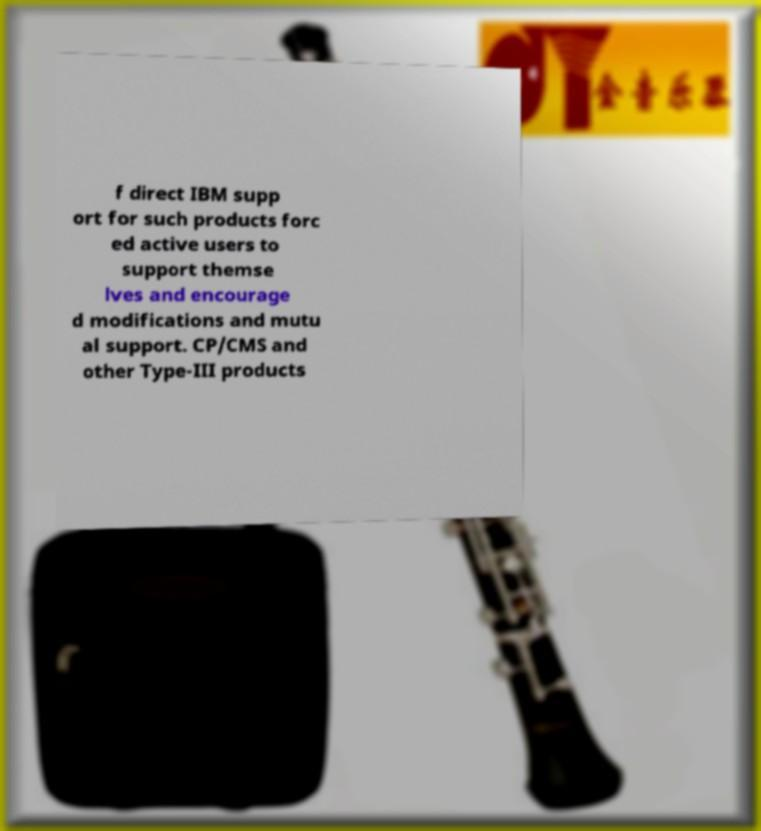Could you extract and type out the text from this image? f direct IBM supp ort for such products forc ed active users to support themse lves and encourage d modifications and mutu al support. CP/CMS and other Type-III products 